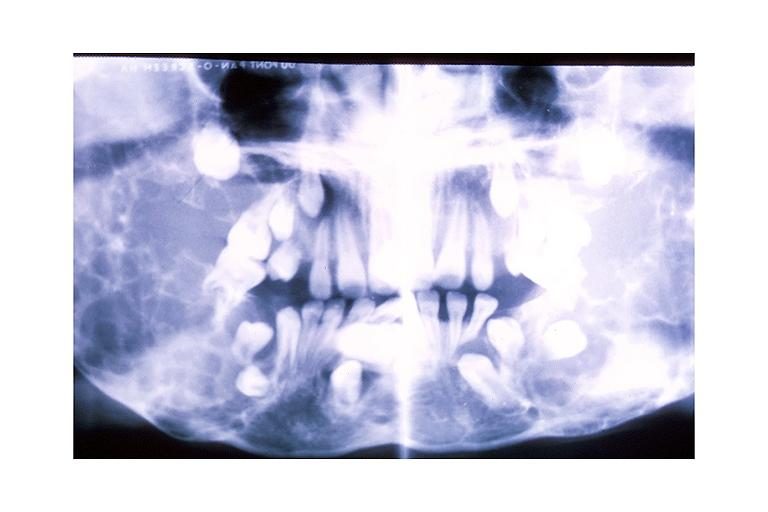s oral present?
Answer the question using a single word or phrase. Yes 